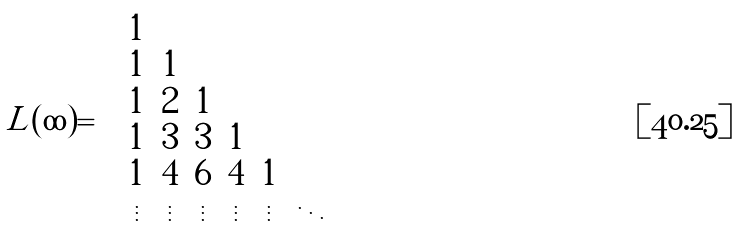Convert formula to latex. <formula><loc_0><loc_0><loc_500><loc_500>L ( \infty ) = \left ( \begin{array} { c c c c c c c } 1 & & & & & \\ 1 & 1 & & & & \\ 1 & 2 & 1 & & & \\ 1 & 3 & 3 & 1 & & \\ 1 & 4 & 6 & 4 & 1 & \\ \vdots & \vdots & \vdots & \vdots & \vdots & \ddots \\ \end{array} \right )</formula> 